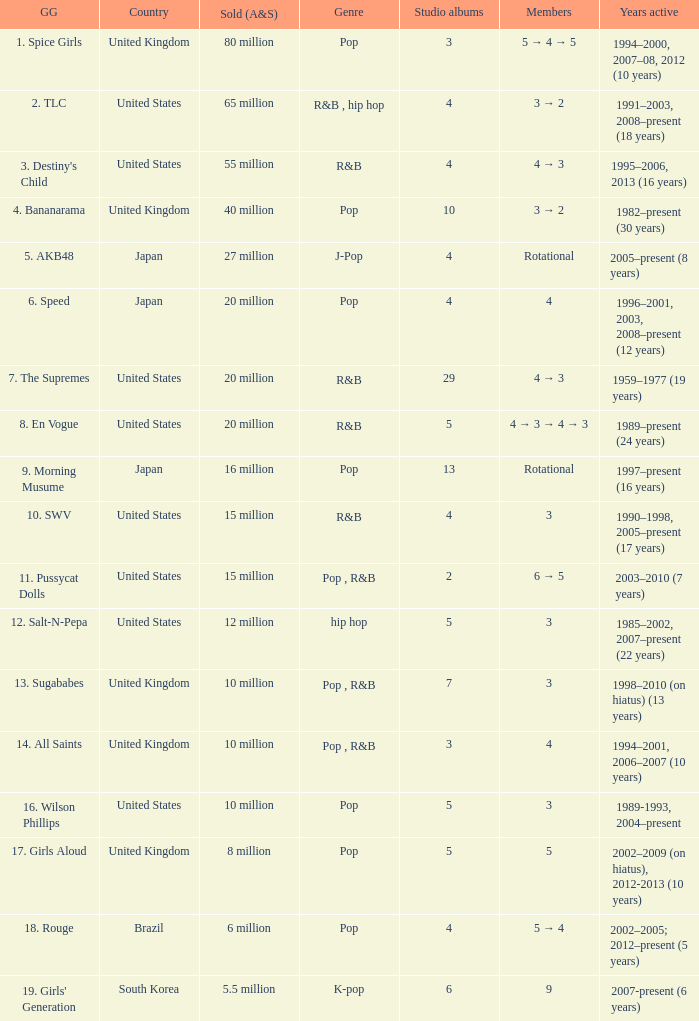What group had 29 studio albums? 7. The Supremes. 